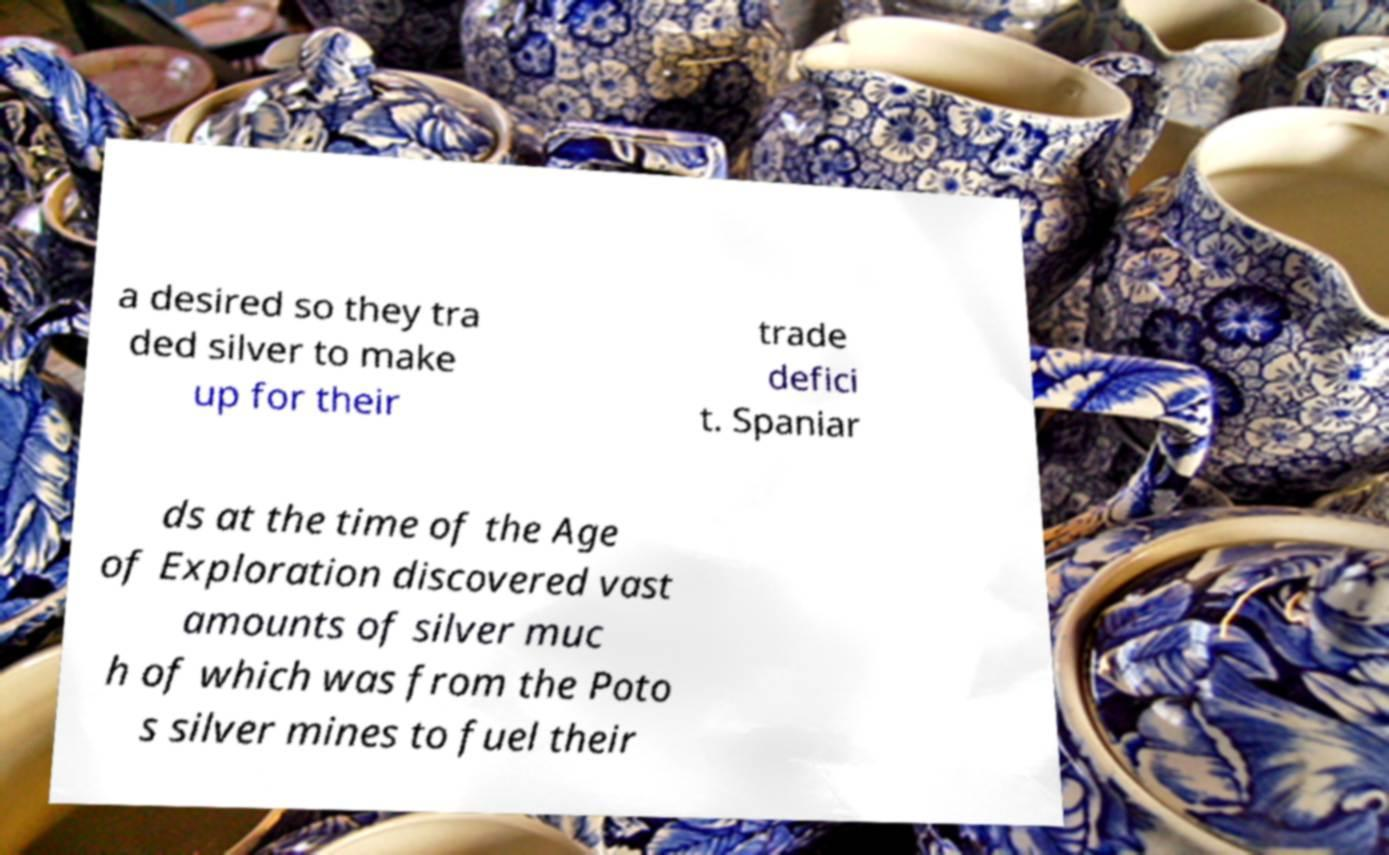Could you extract and type out the text from this image? a desired so they tra ded silver to make up for their trade defici t. Spaniar ds at the time of the Age of Exploration discovered vast amounts of silver muc h of which was from the Poto s silver mines to fuel their 